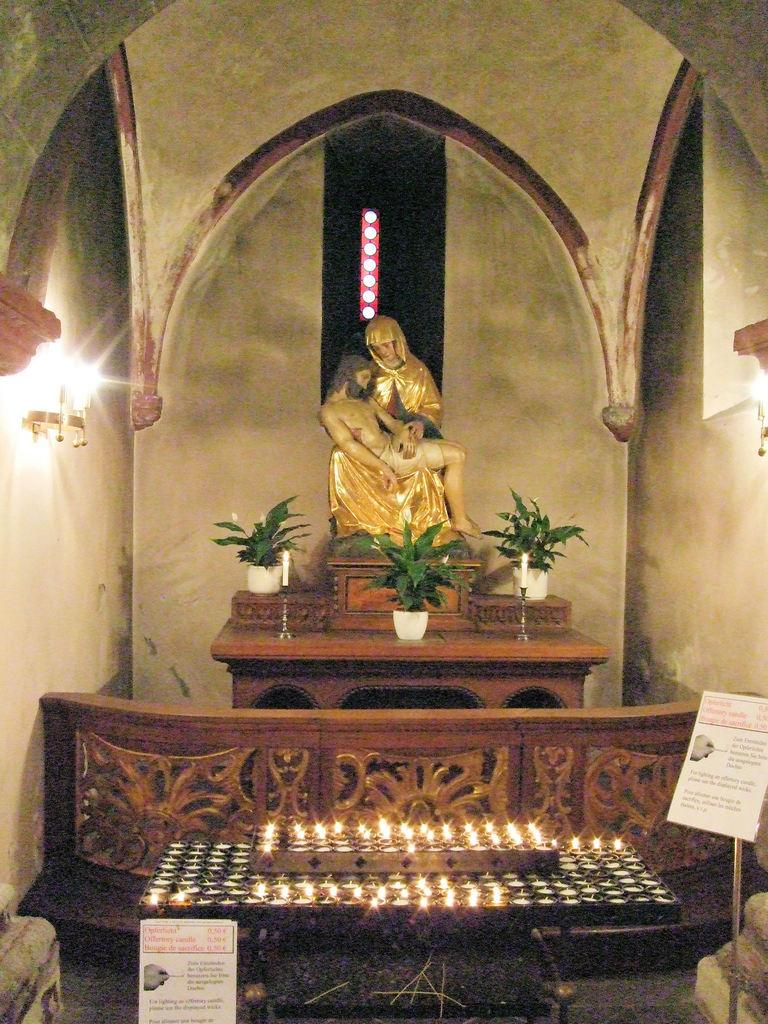What is the main object in the image? There is a statue in the image. Where is the statue placed? The statue is placed on a cupboard. What other items can be seen on the cupboard? Two candles and a group of plants are placed on the cupboard. What can be seen in the background of the image? Lights are placed on the walls in the background of the image. What type of action is the governor taking in the image? There is no governor present in the image, so no action can be attributed to a governor. 